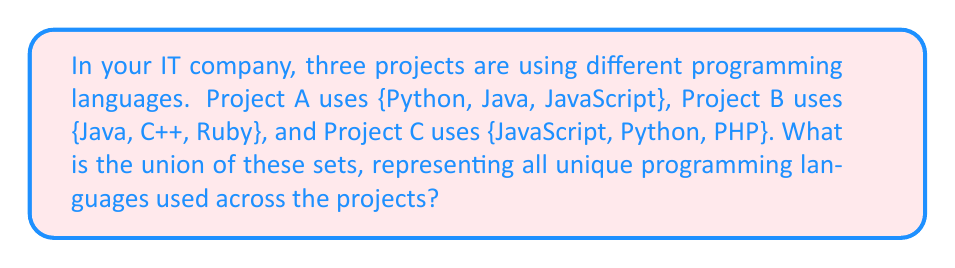Show me your answer to this math problem. Let's approach this step-by-step:

1) First, let's define our sets:
   $A = \{Python, Java, JavaScript\}$
   $B = \{Java, C++, Ruby\}$
   $C = \{JavaScript, Python, PHP\}$

2) We need to find $A \cup B \cup C$, which represents all unique elements from all three sets.

3) Let's start with $A \cup B$:
   $A \cup B = \{Python, Java, JavaScript, C++, Ruby\}$

4) Now, let's add set C:
   $(A \cup B) \cup C = \{Python, Java, JavaScript, C++, Ruby\} \cup \{JavaScript, Python, PHP\}$

5) When we add C, we only need to include elements that are not already in $A \cup B$. The only new element is PHP.

6) Therefore, the final union is:
   $A \cup B \cup C = \{Python, Java, JavaScript, C++, Ruby, PHP\}$

7) Count the elements: There are 6 unique programming languages in the union.
Answer: $A \cup B \cup C = \{Python, Java, JavaScript, C++, Ruby, PHP\}$ 